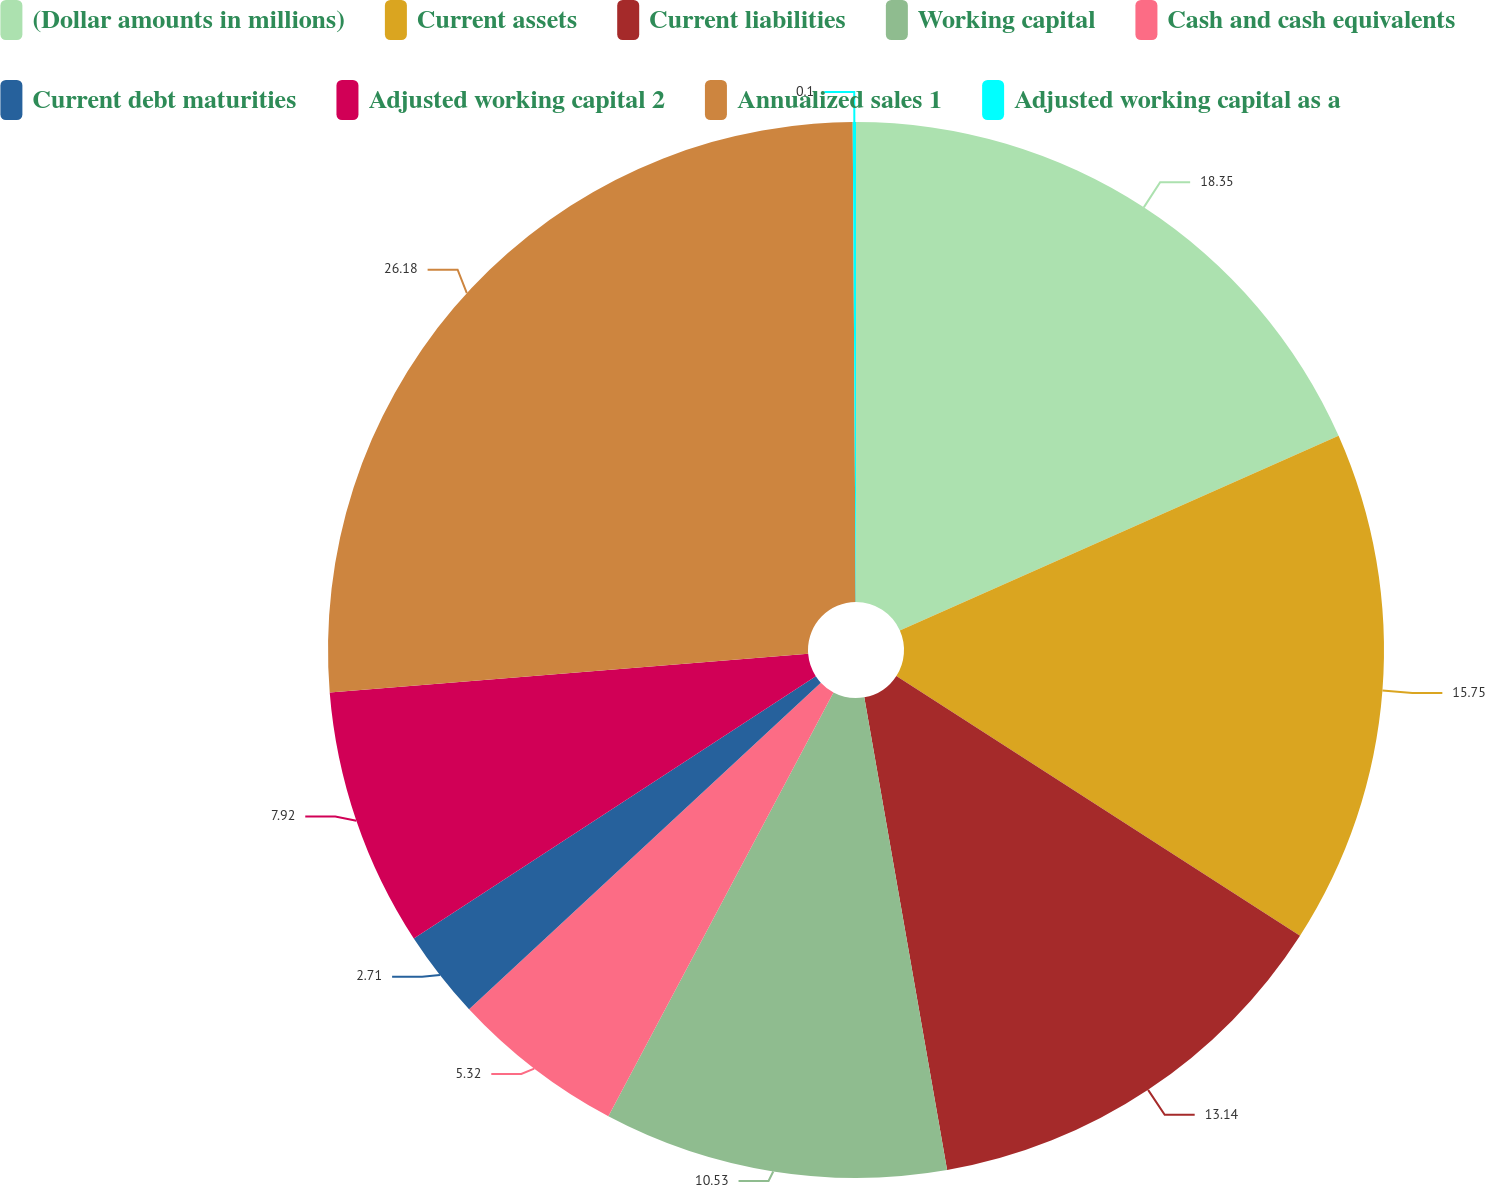Convert chart to OTSL. <chart><loc_0><loc_0><loc_500><loc_500><pie_chart><fcel>(Dollar amounts in millions)<fcel>Current assets<fcel>Current liabilities<fcel>Working capital<fcel>Cash and cash equivalents<fcel>Current debt maturities<fcel>Adjusted working capital 2<fcel>Annualized sales 1<fcel>Adjusted working capital as a<nl><fcel>18.35%<fcel>15.75%<fcel>13.14%<fcel>10.53%<fcel>5.32%<fcel>2.71%<fcel>7.92%<fcel>26.18%<fcel>0.1%<nl></chart> 